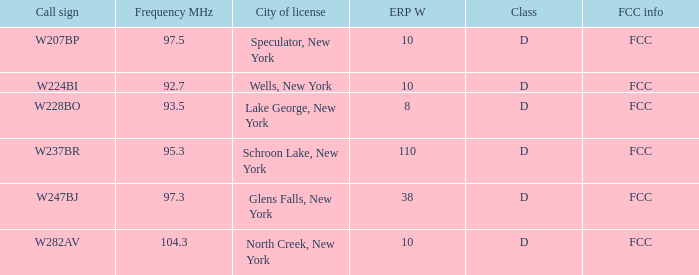Specify the erp w for glens falls, new york 38.0. 